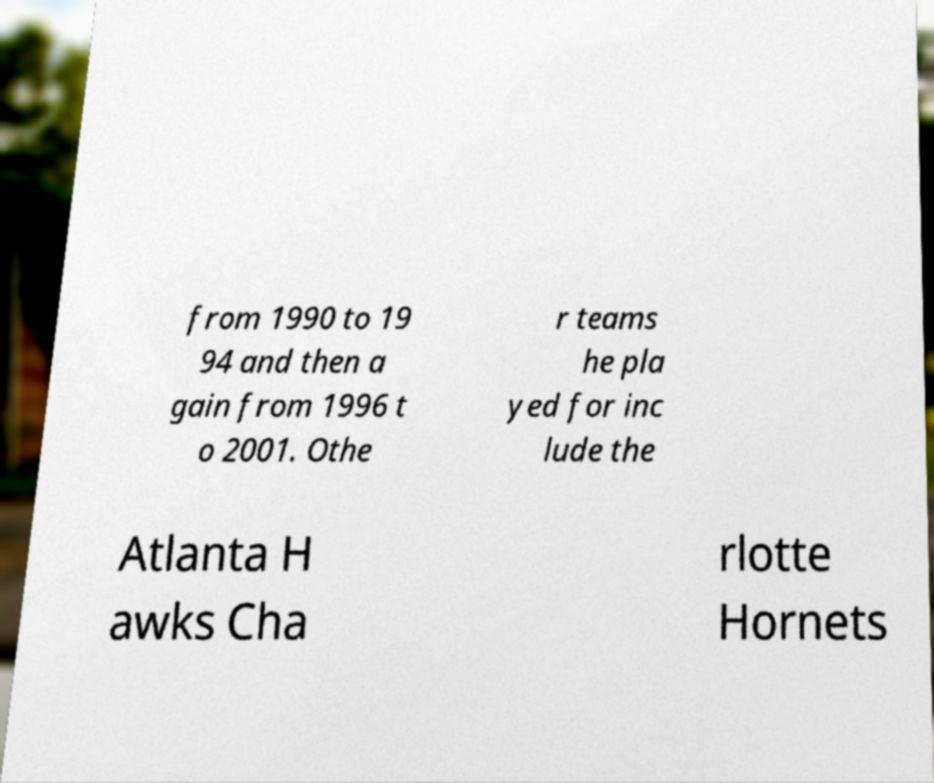I need the written content from this picture converted into text. Can you do that? from 1990 to 19 94 and then a gain from 1996 t o 2001. Othe r teams he pla yed for inc lude the Atlanta H awks Cha rlotte Hornets 